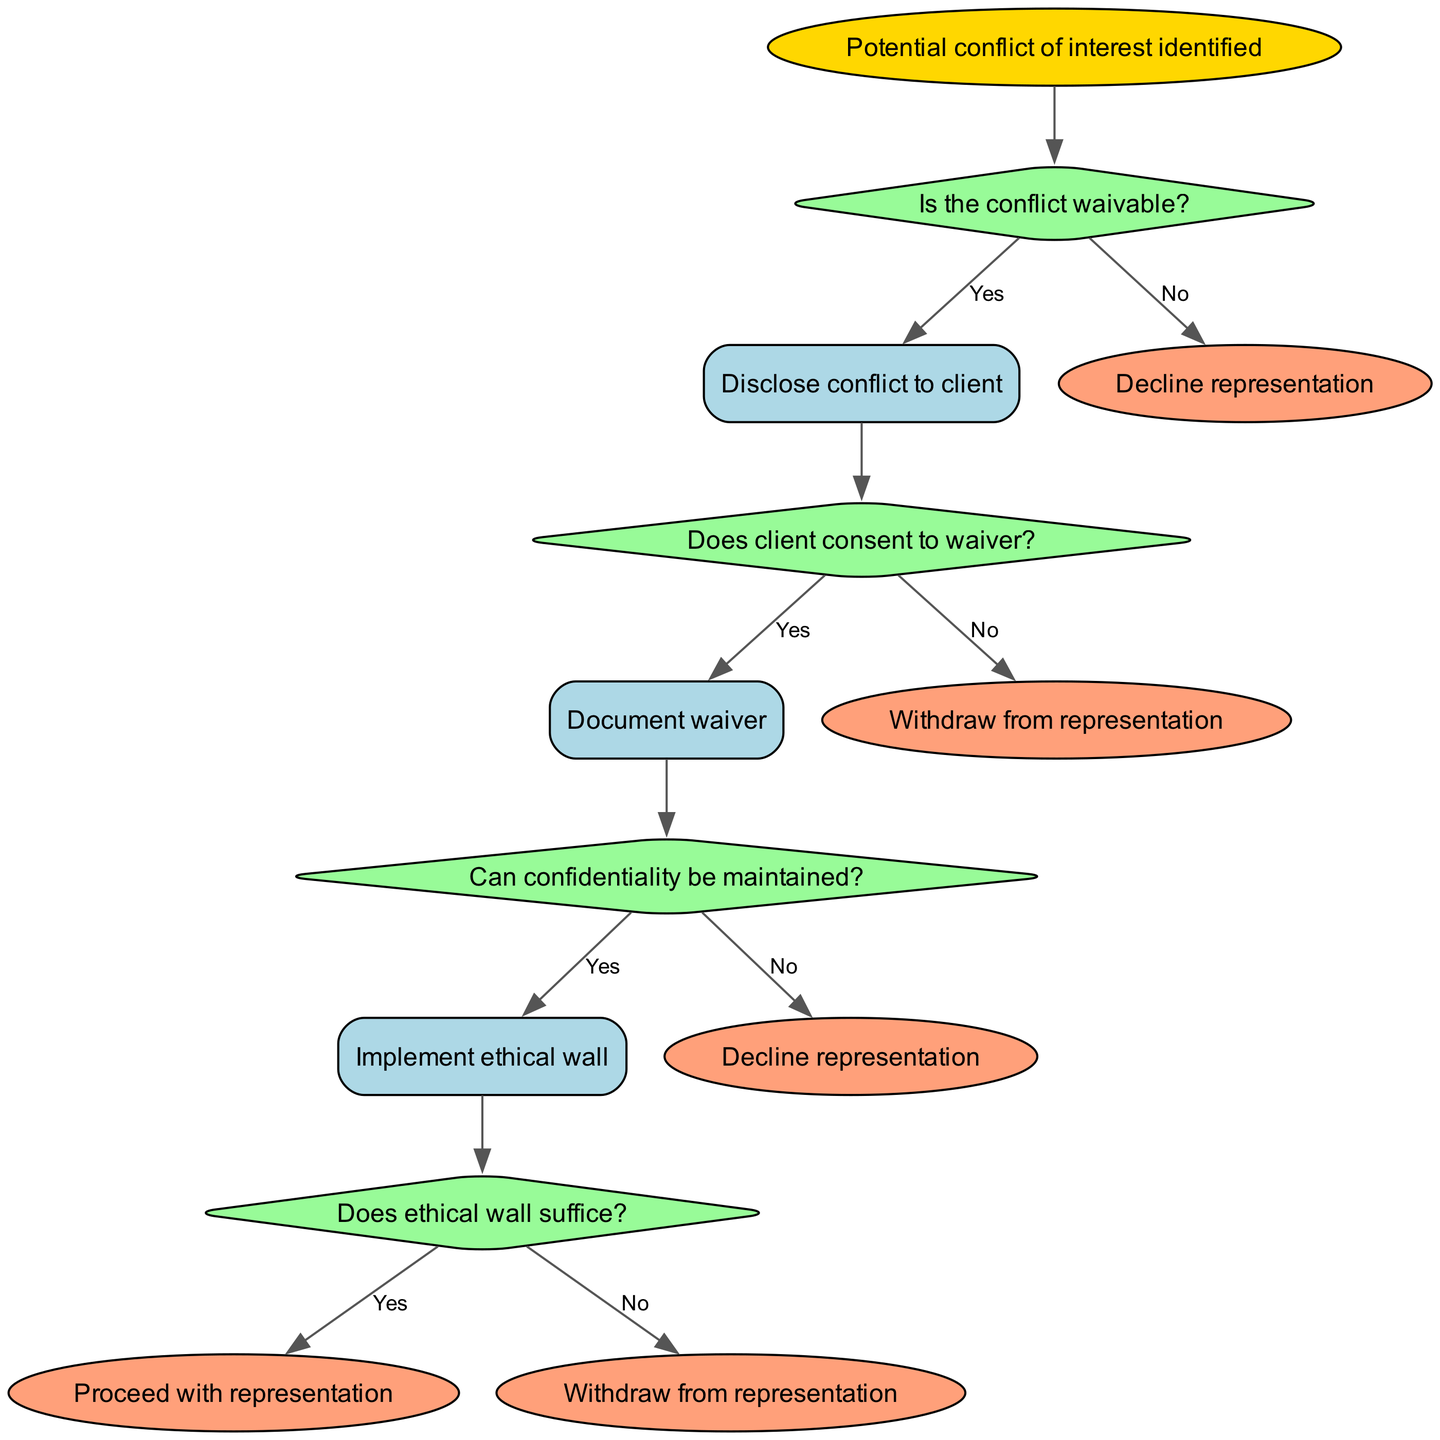What is the root of the decision tree? The root of the decision tree is the starting point of the decision-making process. Here, it states that a "Potential conflict of interest identified," which sets the context for the decisions that follow.
Answer: Potential conflict of interest identified How many main decisions are presented in the diagram? The diagram presents four main decisions regarding handling potential conflicts of interest, each linked to different courses of action.
Answer: 4 What do you do if the conflict is waivable? If the conflict is waivable, the action in the diagram specifies that one should "Disclose conflict to client." This is the immediate next step after determining that the conflict can be waived.
Answer: Disclose conflict to client What is the outcome if the client does not consent to the waiver? If the client does not consent to the waiver, the diagram indicates that the action to take is to "Withdraw from representation." This ensures that the lawyer acts ethically and avoids proceeding in a situation that could harm the client.
Answer: Withdraw from representation What happens after implementing the ethical wall if it suffices? If the ethical wall suffices, the diagram shows that the process allows one to proceed with representation, indicating that the conflict has been managed adequately at that stage.
Answer: Proceed with representation What is the result if confidentiality cannot be maintained? According to the diagram, if confidentiality cannot be maintained, the appropriate result would be to "Decline representation." This helps prevent any breach of confidentiality, ensuring compliance with ethical standards.
Answer: Decline representation What is the next action if the conflict is not waivable? If the conflict is not waivable, the immediate action specified in the diagram is to "Decline representation," indicating that the lawyer should refrain from taking on that case due to ethical concerns.
Answer: Decline representation What should be documented if the client consents to the waiver? If the client consents to the waiver, the diagram states that one should "Document waiver," highlighting the importance of maintaining records for ethical compliance and future reference.
Answer: Document waiver What is required after the ethical wall is implemented? After implementing the ethical wall, the diagram requires determining if it suffices to protect confidentiality before proceeding. This step is critical for ensuring that the conflict is effectively managed and ethical obligations are met.
Answer: Determine sufficiency of ethical wall 